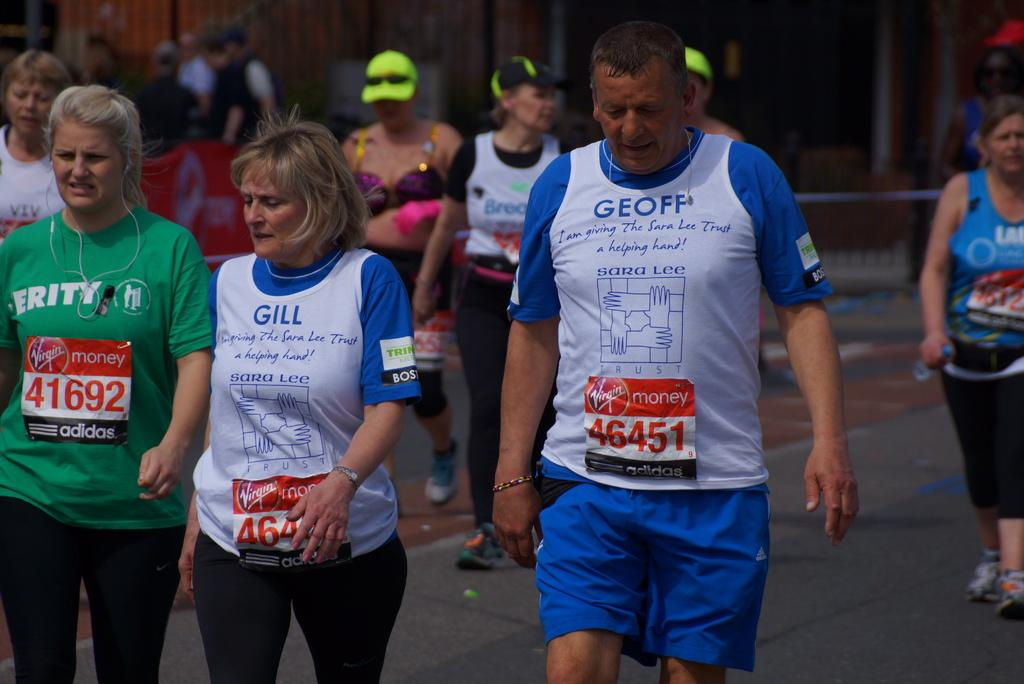<image>
Share a concise interpretation of the image provided. Some people running, one of the right has the name Geoff on his shirt. 